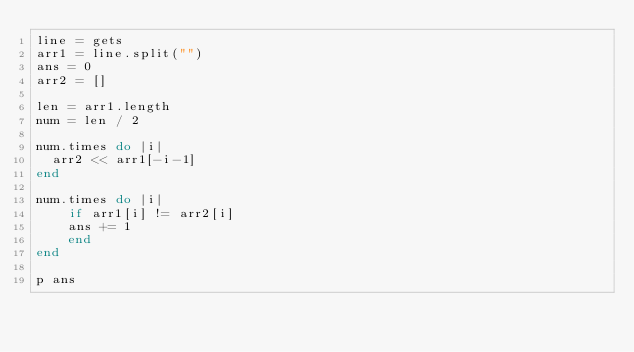<code> <loc_0><loc_0><loc_500><loc_500><_Ruby_>line = gets
arr1 = line.split("")
ans = 0
arr2 = []

len = arr1.length
num = len / 2

num.times do |i|
	arr2 << arr1[-i-1]
end

num.times do |i|
  	if arr1[i] != arr2[i]
    ans += 1
    end
end

p ans</code> 